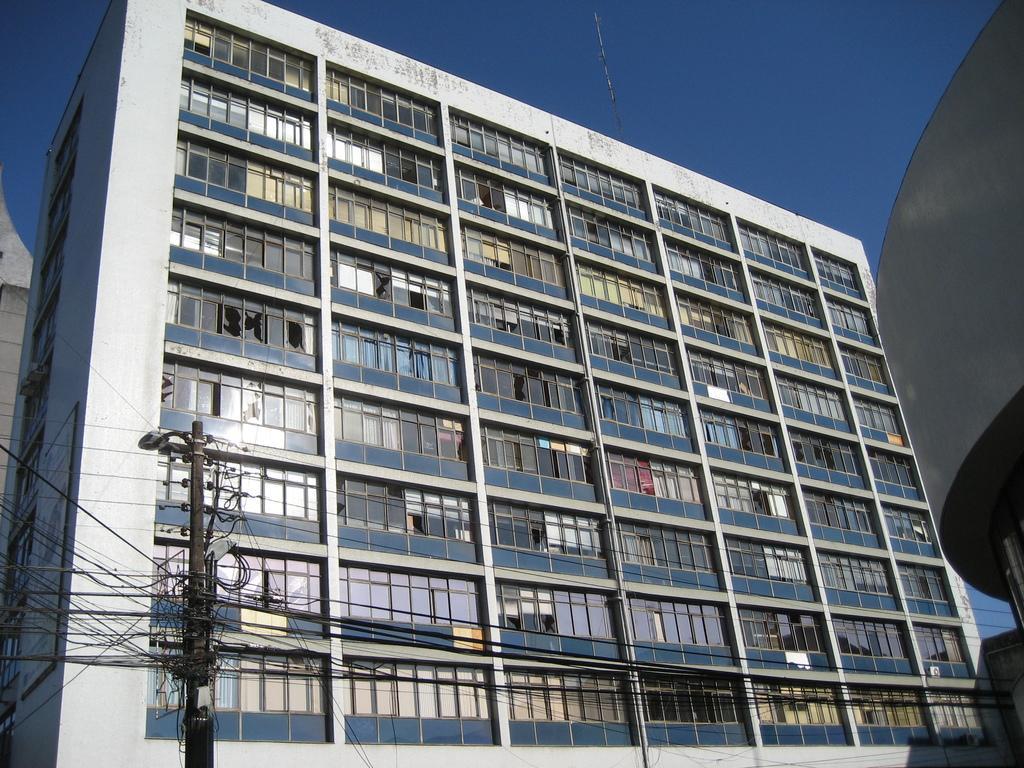Can you describe this image briefly? Here we can see a building, pole, and wires. In the background there is sky. 